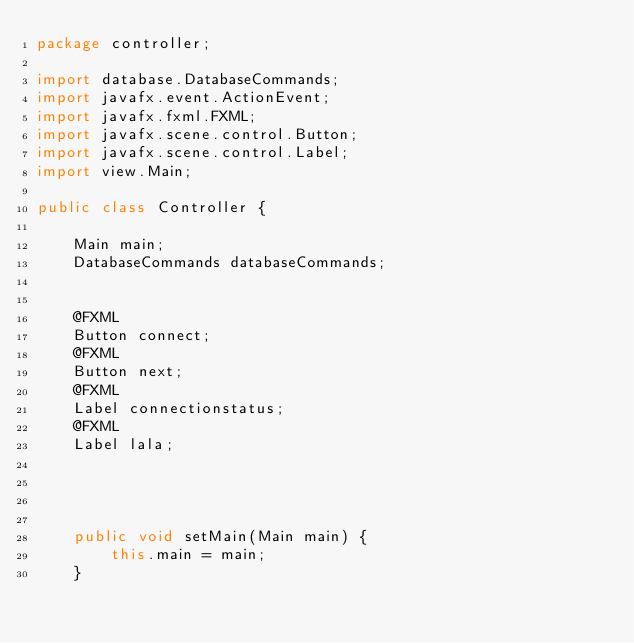Convert code to text. <code><loc_0><loc_0><loc_500><loc_500><_Java_>package controller;

import database.DatabaseCommands;
import javafx.event.ActionEvent;
import javafx.fxml.FXML;
import javafx.scene.control.Button;
import javafx.scene.control.Label;
import view.Main;

public class Controller {

    Main main;
    DatabaseCommands databaseCommands;


    @FXML
    Button connect;
    @FXML
    Button next;
    @FXML
    Label connectionstatus;
    @FXML
    Label lala;




    public void setMain(Main main) {
        this.main = main;
    }
</code> 